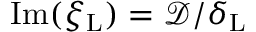Convert formula to latex. <formula><loc_0><loc_0><loc_500><loc_500>I m ( { \xi _ { L } } ) = \mathcal { D } / \delta _ { L }</formula> 